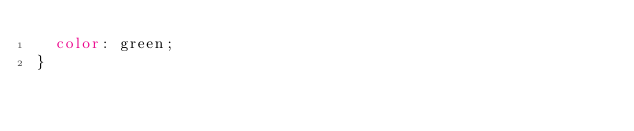<code> <loc_0><loc_0><loc_500><loc_500><_CSS_>  color: green;
}</code> 